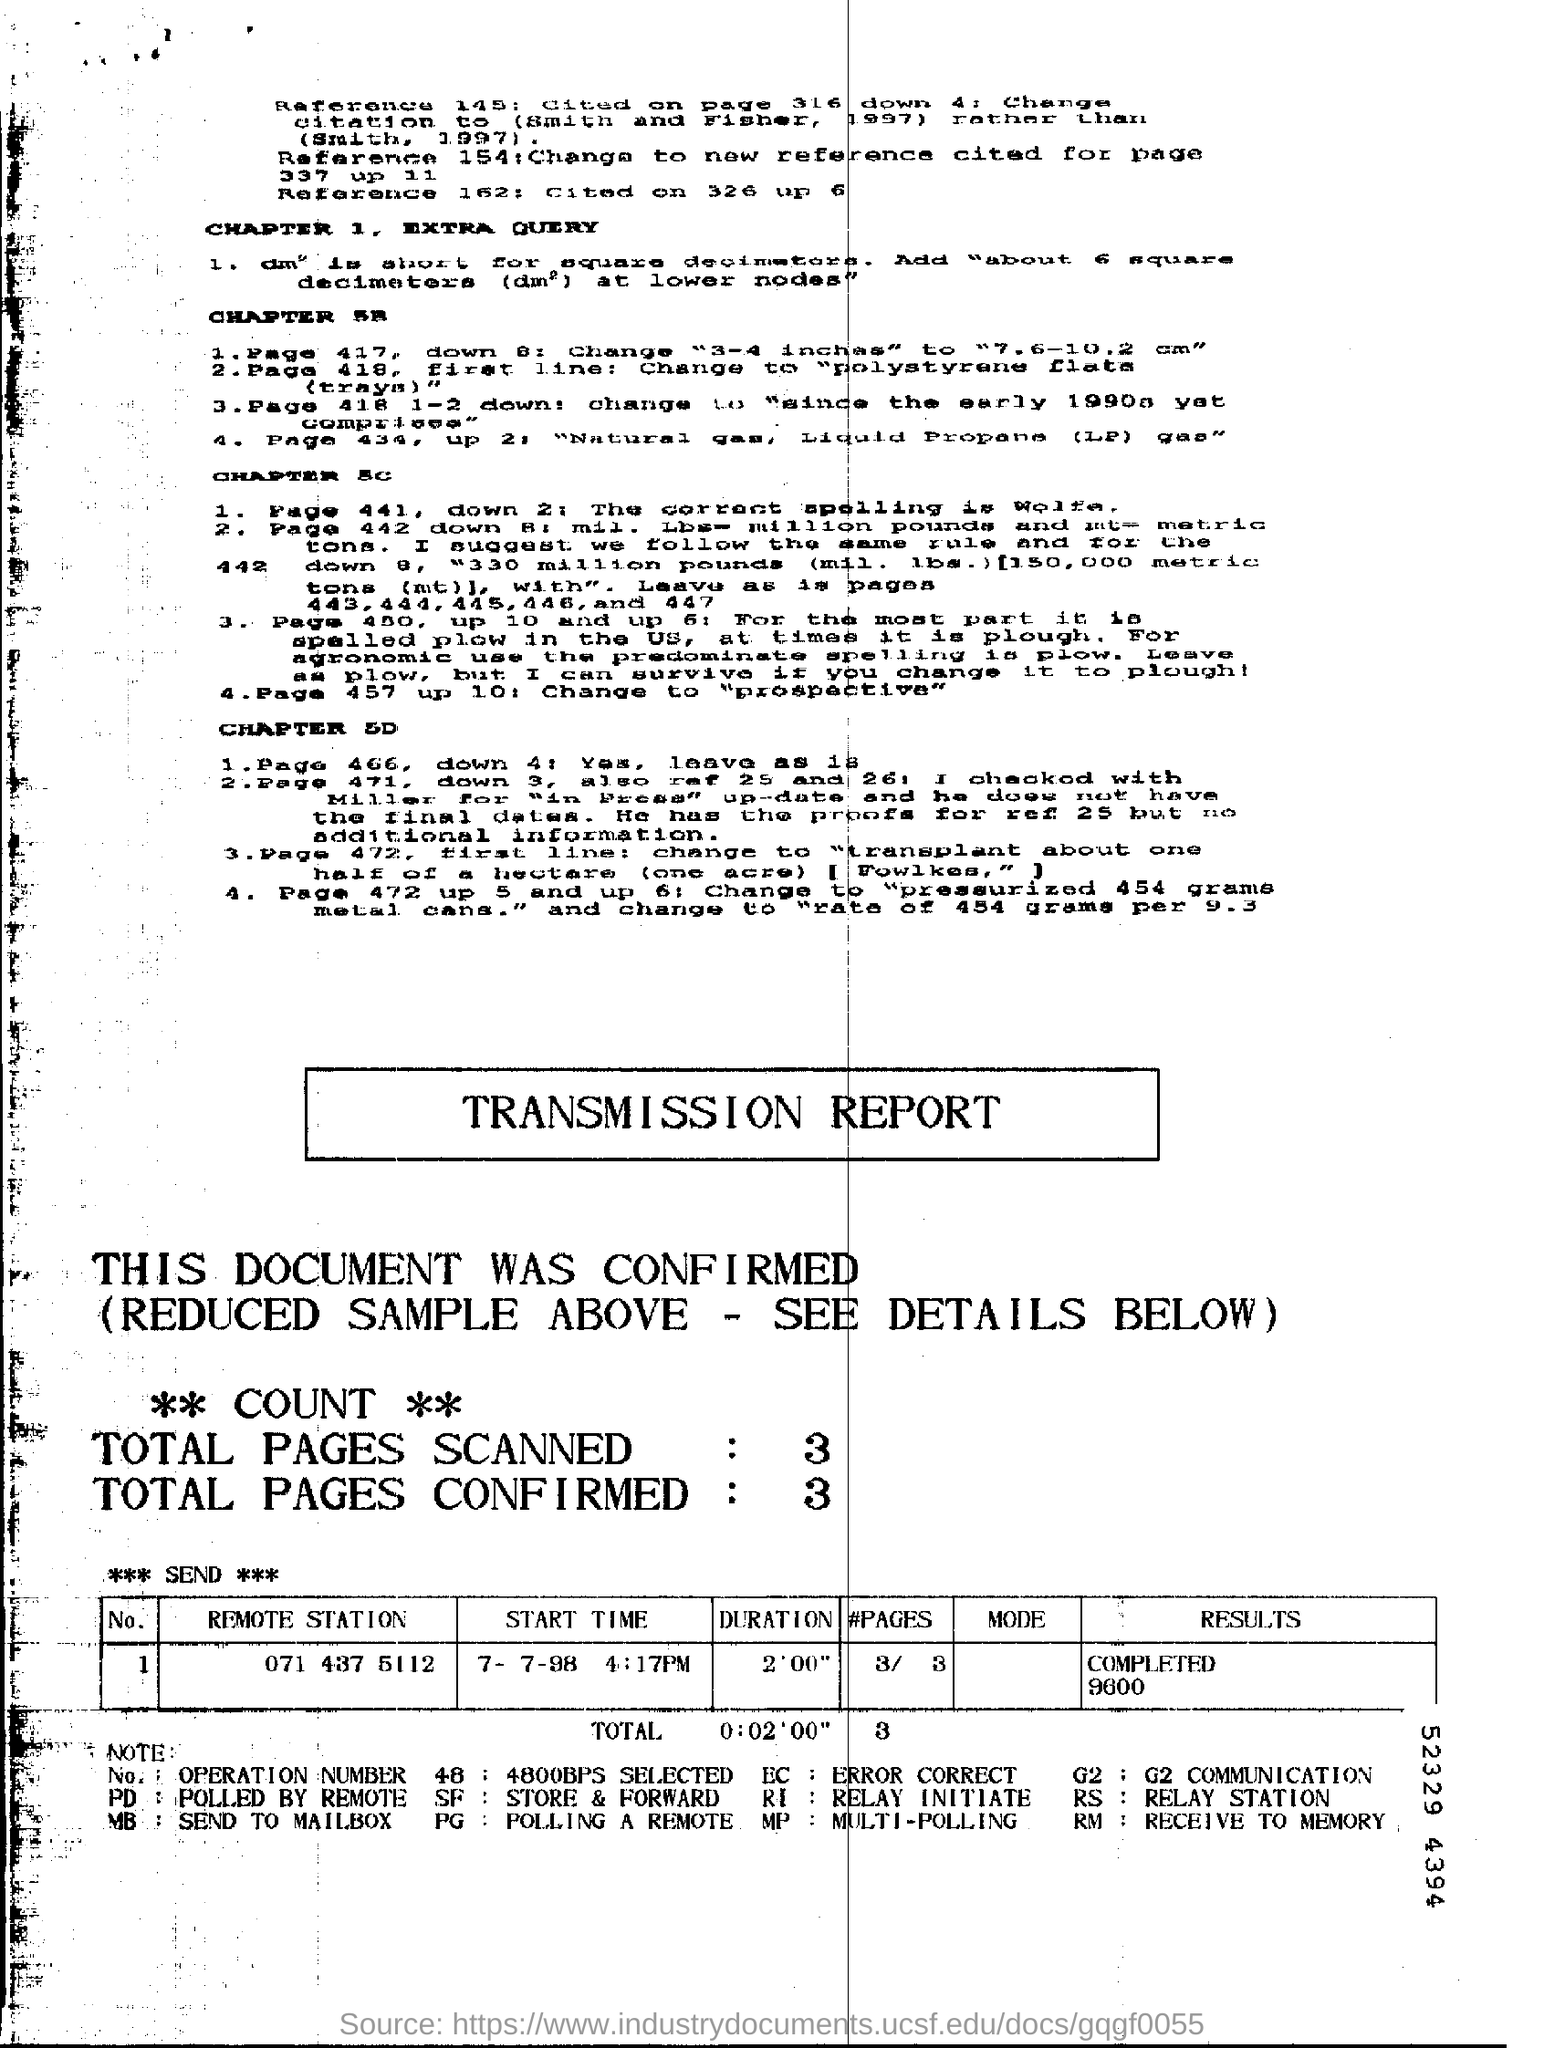Highlight a few significant elements in this photo. I scanned a total of 3 pages. There are 3 pages confirmed in total. 